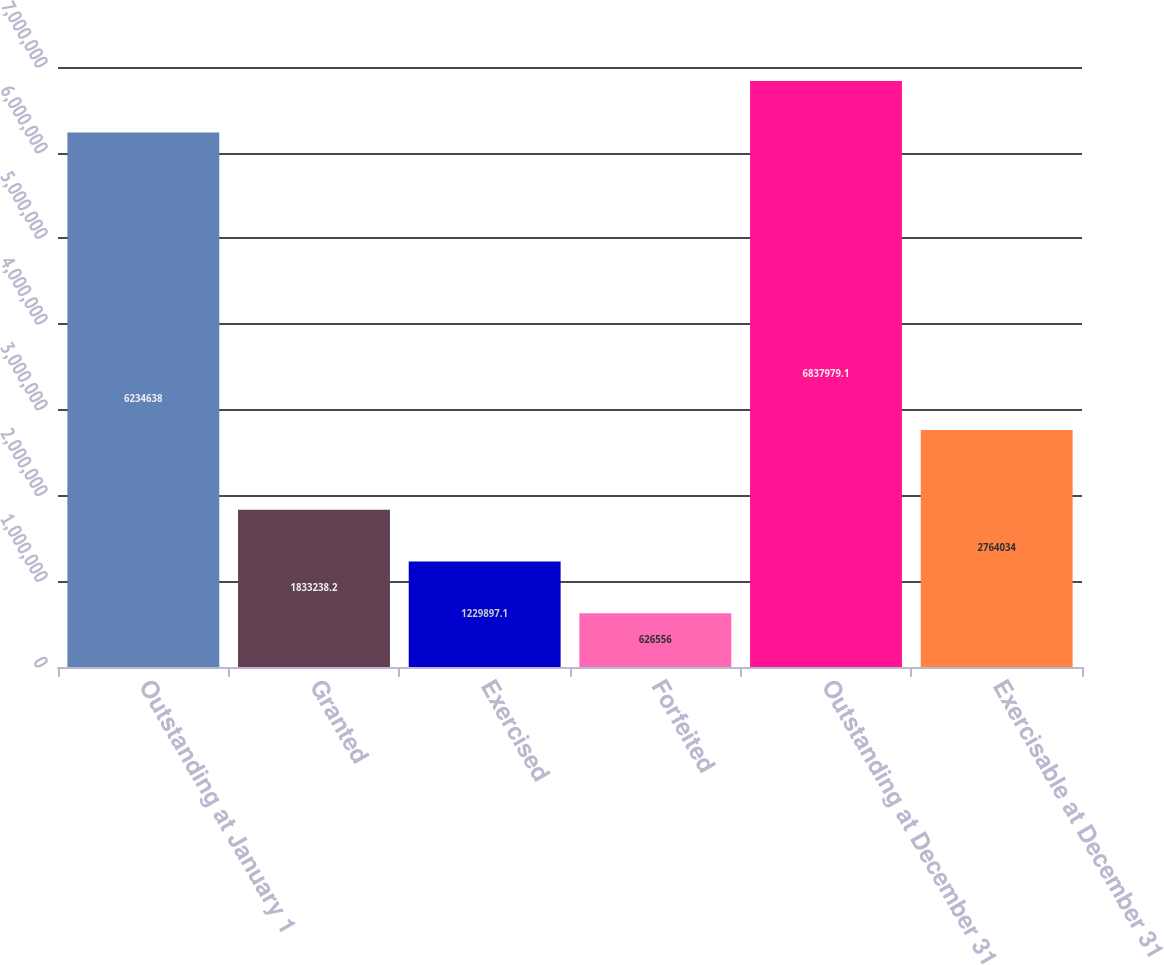Convert chart. <chart><loc_0><loc_0><loc_500><loc_500><bar_chart><fcel>Outstanding at January 1<fcel>Granted<fcel>Exercised<fcel>Forfeited<fcel>Outstanding at December 31<fcel>Exercisable at December 31<nl><fcel>6.23464e+06<fcel>1.83324e+06<fcel>1.2299e+06<fcel>626556<fcel>6.83798e+06<fcel>2.76403e+06<nl></chart> 